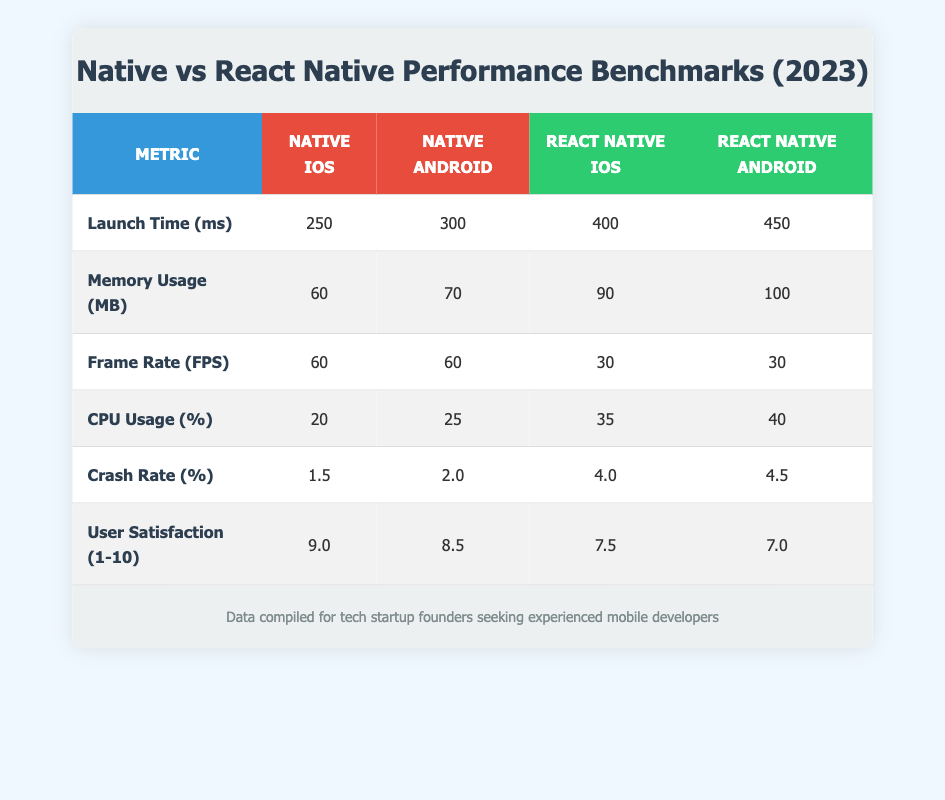What is the launch time for React Native on iOS? The table indicates that the launch time for React Native on iOS is 400 ms.
Answer: 400 ms Which platform has a higher memory usage, native Android or React Native iOS? The table shows that memory usage for native Android is 70 MB, while for React Native iOS it's 90 MB. Since 90 MB is greater than 70 MB, React Native iOS has higher memory usage.
Answer: React Native iOS What is the average crash rate for both native platforms? The crash rates for native iOS and Android are 1.5% and 2.0% respectively. To find the average, sum both values: 1.5 + 2.0 = 3.5, then divide by 2: 3.5 / 2 = 1.75%.
Answer: 1.75% Is the CPU usage for React Native on Android greater than that for native Android? The CPU usage is 40% for React Native on Android and 25% for native Android. Since 40% is greater than 25%, the answer is yes.
Answer: Yes What is the difference in user satisfaction scores between native iOS and React Native iOS? The user satisfaction score for native iOS is 9.0, and for React Native iOS it is 7.5. To find the difference, subtract: 9.0 - 7.5 = 1.5.
Answer: 1.5 